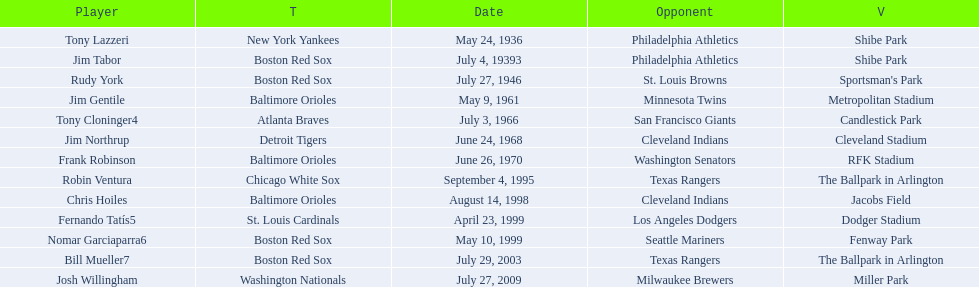What is the name of the player for the new york yankees in 1936? Tony Lazzeri. 